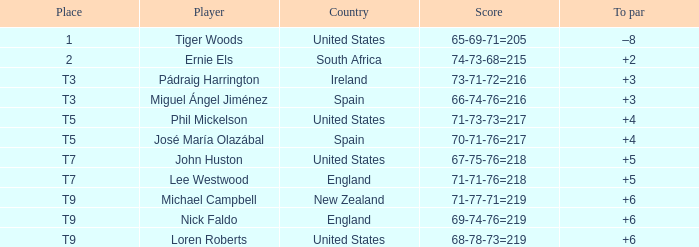What is the player when the result is "66-74-76=216"? Miguel Ángel Jiménez. 